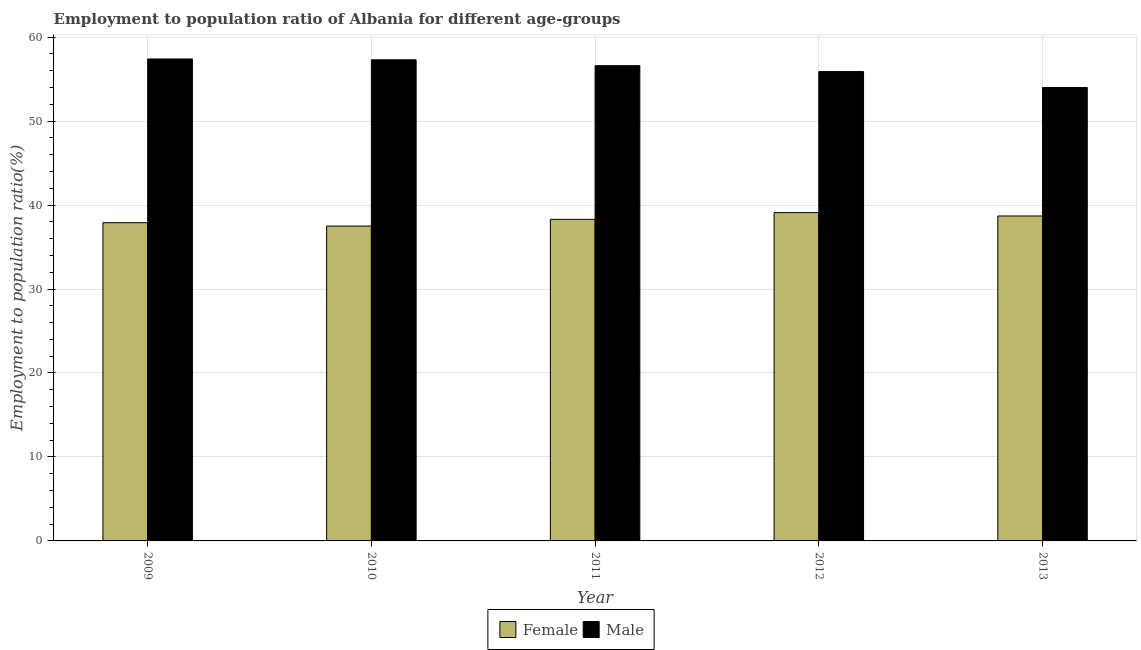How many groups of bars are there?
Your answer should be very brief. 5. How many bars are there on the 5th tick from the left?
Your answer should be compact. 2. How many bars are there on the 2nd tick from the right?
Your answer should be very brief. 2. In how many cases, is the number of bars for a given year not equal to the number of legend labels?
Your answer should be very brief. 0. What is the employment to population ratio(female) in 2009?
Offer a terse response. 37.9. Across all years, what is the maximum employment to population ratio(female)?
Offer a terse response. 39.1. Across all years, what is the minimum employment to population ratio(female)?
Offer a terse response. 37.5. In which year was the employment to population ratio(female) maximum?
Ensure brevity in your answer.  2012. What is the total employment to population ratio(female) in the graph?
Offer a very short reply. 191.5. What is the difference between the employment to population ratio(female) in 2009 and that in 2010?
Offer a terse response. 0.4. What is the difference between the employment to population ratio(male) in 2009 and the employment to population ratio(female) in 2013?
Give a very brief answer. 3.4. What is the average employment to population ratio(male) per year?
Offer a terse response. 56.24. In the year 2012, what is the difference between the employment to population ratio(male) and employment to population ratio(female)?
Offer a very short reply. 0. In how many years, is the employment to population ratio(female) greater than 24 %?
Your response must be concise. 5. What is the ratio of the employment to population ratio(male) in 2009 to that in 2012?
Give a very brief answer. 1.03. Is the employment to population ratio(female) in 2009 less than that in 2012?
Offer a very short reply. Yes. Is the difference between the employment to population ratio(female) in 2010 and 2013 greater than the difference between the employment to population ratio(male) in 2010 and 2013?
Offer a very short reply. No. What is the difference between the highest and the second highest employment to population ratio(male)?
Your response must be concise. 0.1. What is the difference between the highest and the lowest employment to population ratio(male)?
Offer a terse response. 3.4. In how many years, is the employment to population ratio(female) greater than the average employment to population ratio(female) taken over all years?
Ensure brevity in your answer.  2. What does the 1st bar from the right in 2011 represents?
Give a very brief answer. Male. How many bars are there?
Your answer should be compact. 10. Are all the bars in the graph horizontal?
Your answer should be compact. No. Are the values on the major ticks of Y-axis written in scientific E-notation?
Provide a short and direct response. No. Does the graph contain any zero values?
Give a very brief answer. No. How many legend labels are there?
Your answer should be very brief. 2. What is the title of the graph?
Make the answer very short. Employment to population ratio of Albania for different age-groups. What is the label or title of the X-axis?
Your answer should be compact. Year. What is the Employment to population ratio(%) of Female in 2009?
Provide a succinct answer. 37.9. What is the Employment to population ratio(%) in Male in 2009?
Your response must be concise. 57.4. What is the Employment to population ratio(%) in Female in 2010?
Ensure brevity in your answer.  37.5. What is the Employment to population ratio(%) in Male in 2010?
Keep it short and to the point. 57.3. What is the Employment to population ratio(%) in Female in 2011?
Provide a short and direct response. 38.3. What is the Employment to population ratio(%) in Male in 2011?
Provide a short and direct response. 56.6. What is the Employment to population ratio(%) of Female in 2012?
Your answer should be compact. 39.1. What is the Employment to population ratio(%) in Male in 2012?
Provide a short and direct response. 55.9. What is the Employment to population ratio(%) in Female in 2013?
Provide a short and direct response. 38.7. What is the Employment to population ratio(%) in Male in 2013?
Keep it short and to the point. 54. Across all years, what is the maximum Employment to population ratio(%) in Female?
Your answer should be very brief. 39.1. Across all years, what is the maximum Employment to population ratio(%) in Male?
Keep it short and to the point. 57.4. Across all years, what is the minimum Employment to population ratio(%) in Female?
Your answer should be very brief. 37.5. Across all years, what is the minimum Employment to population ratio(%) in Male?
Provide a succinct answer. 54. What is the total Employment to population ratio(%) of Female in the graph?
Ensure brevity in your answer.  191.5. What is the total Employment to population ratio(%) of Male in the graph?
Make the answer very short. 281.2. What is the difference between the Employment to population ratio(%) of Female in 2009 and that in 2011?
Offer a very short reply. -0.4. What is the difference between the Employment to population ratio(%) in Male in 2009 and that in 2011?
Make the answer very short. 0.8. What is the difference between the Employment to population ratio(%) in Female in 2009 and that in 2012?
Your answer should be compact. -1.2. What is the difference between the Employment to population ratio(%) of Male in 2009 and that in 2013?
Your answer should be very brief. 3.4. What is the difference between the Employment to population ratio(%) of Female in 2010 and that in 2011?
Provide a succinct answer. -0.8. What is the difference between the Employment to population ratio(%) in Male in 2010 and that in 2013?
Keep it short and to the point. 3.3. What is the difference between the Employment to population ratio(%) of Male in 2011 and that in 2012?
Your answer should be very brief. 0.7. What is the difference between the Employment to population ratio(%) in Female in 2011 and that in 2013?
Give a very brief answer. -0.4. What is the difference between the Employment to population ratio(%) of Female in 2012 and that in 2013?
Provide a short and direct response. 0.4. What is the difference between the Employment to population ratio(%) in Male in 2012 and that in 2013?
Keep it short and to the point. 1.9. What is the difference between the Employment to population ratio(%) in Female in 2009 and the Employment to population ratio(%) in Male in 2010?
Offer a terse response. -19.4. What is the difference between the Employment to population ratio(%) in Female in 2009 and the Employment to population ratio(%) in Male in 2011?
Give a very brief answer. -18.7. What is the difference between the Employment to population ratio(%) of Female in 2009 and the Employment to population ratio(%) of Male in 2013?
Offer a terse response. -16.1. What is the difference between the Employment to population ratio(%) of Female in 2010 and the Employment to population ratio(%) of Male in 2011?
Your answer should be compact. -19.1. What is the difference between the Employment to population ratio(%) in Female in 2010 and the Employment to population ratio(%) in Male in 2012?
Offer a very short reply. -18.4. What is the difference between the Employment to population ratio(%) of Female in 2010 and the Employment to population ratio(%) of Male in 2013?
Make the answer very short. -16.5. What is the difference between the Employment to population ratio(%) in Female in 2011 and the Employment to population ratio(%) in Male in 2012?
Provide a short and direct response. -17.6. What is the difference between the Employment to population ratio(%) of Female in 2011 and the Employment to population ratio(%) of Male in 2013?
Your response must be concise. -15.7. What is the difference between the Employment to population ratio(%) in Female in 2012 and the Employment to population ratio(%) in Male in 2013?
Ensure brevity in your answer.  -14.9. What is the average Employment to population ratio(%) in Female per year?
Keep it short and to the point. 38.3. What is the average Employment to population ratio(%) of Male per year?
Ensure brevity in your answer.  56.24. In the year 2009, what is the difference between the Employment to population ratio(%) of Female and Employment to population ratio(%) of Male?
Offer a terse response. -19.5. In the year 2010, what is the difference between the Employment to population ratio(%) in Female and Employment to population ratio(%) in Male?
Your answer should be compact. -19.8. In the year 2011, what is the difference between the Employment to population ratio(%) of Female and Employment to population ratio(%) of Male?
Your answer should be compact. -18.3. In the year 2012, what is the difference between the Employment to population ratio(%) of Female and Employment to population ratio(%) of Male?
Make the answer very short. -16.8. In the year 2013, what is the difference between the Employment to population ratio(%) of Female and Employment to population ratio(%) of Male?
Ensure brevity in your answer.  -15.3. What is the ratio of the Employment to population ratio(%) in Female in 2009 to that in 2010?
Keep it short and to the point. 1.01. What is the ratio of the Employment to population ratio(%) of Female in 2009 to that in 2011?
Make the answer very short. 0.99. What is the ratio of the Employment to population ratio(%) in Male in 2009 to that in 2011?
Make the answer very short. 1.01. What is the ratio of the Employment to population ratio(%) of Female in 2009 to that in 2012?
Your answer should be very brief. 0.97. What is the ratio of the Employment to population ratio(%) of Male in 2009 to that in 2012?
Provide a succinct answer. 1.03. What is the ratio of the Employment to population ratio(%) in Female in 2009 to that in 2013?
Make the answer very short. 0.98. What is the ratio of the Employment to population ratio(%) in Male in 2009 to that in 2013?
Offer a terse response. 1.06. What is the ratio of the Employment to population ratio(%) in Female in 2010 to that in 2011?
Your answer should be compact. 0.98. What is the ratio of the Employment to population ratio(%) in Male in 2010 to that in 2011?
Your response must be concise. 1.01. What is the ratio of the Employment to population ratio(%) of Female in 2010 to that in 2012?
Give a very brief answer. 0.96. What is the ratio of the Employment to population ratio(%) of Female in 2010 to that in 2013?
Provide a short and direct response. 0.97. What is the ratio of the Employment to population ratio(%) of Male in 2010 to that in 2013?
Provide a succinct answer. 1.06. What is the ratio of the Employment to population ratio(%) in Female in 2011 to that in 2012?
Provide a succinct answer. 0.98. What is the ratio of the Employment to population ratio(%) in Male in 2011 to that in 2012?
Your answer should be very brief. 1.01. What is the ratio of the Employment to population ratio(%) of Male in 2011 to that in 2013?
Your answer should be compact. 1.05. What is the ratio of the Employment to population ratio(%) in Female in 2012 to that in 2013?
Give a very brief answer. 1.01. What is the ratio of the Employment to population ratio(%) in Male in 2012 to that in 2013?
Give a very brief answer. 1.04. What is the difference between the highest and the second highest Employment to population ratio(%) in Female?
Your response must be concise. 0.4. What is the difference between the highest and the second highest Employment to population ratio(%) of Male?
Your response must be concise. 0.1. 